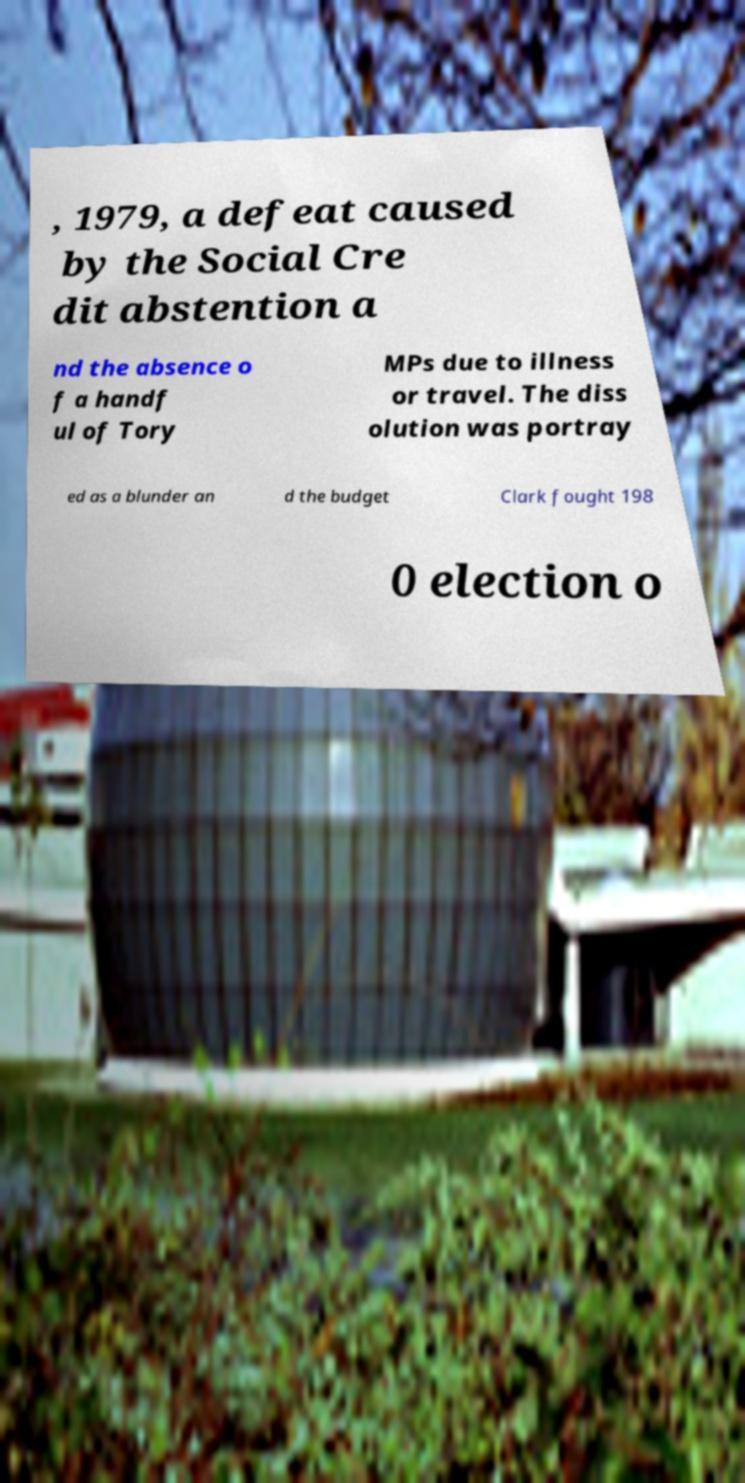Can you accurately transcribe the text from the provided image for me? , 1979, a defeat caused by the Social Cre dit abstention a nd the absence o f a handf ul of Tory MPs due to illness or travel. The diss olution was portray ed as a blunder an d the budget Clark fought 198 0 election o 